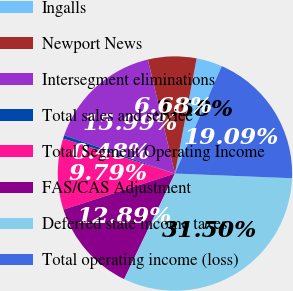Convert chart. <chart><loc_0><loc_0><loc_500><loc_500><pie_chart><fcel>Ingalls<fcel>Newport News<fcel>Intersegment eliminations<fcel>Total sales and service<fcel>Total Segment Operating Income<fcel>FAS/CAS Adjustment<fcel>Deferred state income taxes<fcel>Total operating income (loss)<nl><fcel>3.58%<fcel>6.68%<fcel>15.99%<fcel>0.48%<fcel>9.79%<fcel>12.89%<fcel>31.5%<fcel>19.09%<nl></chart> 